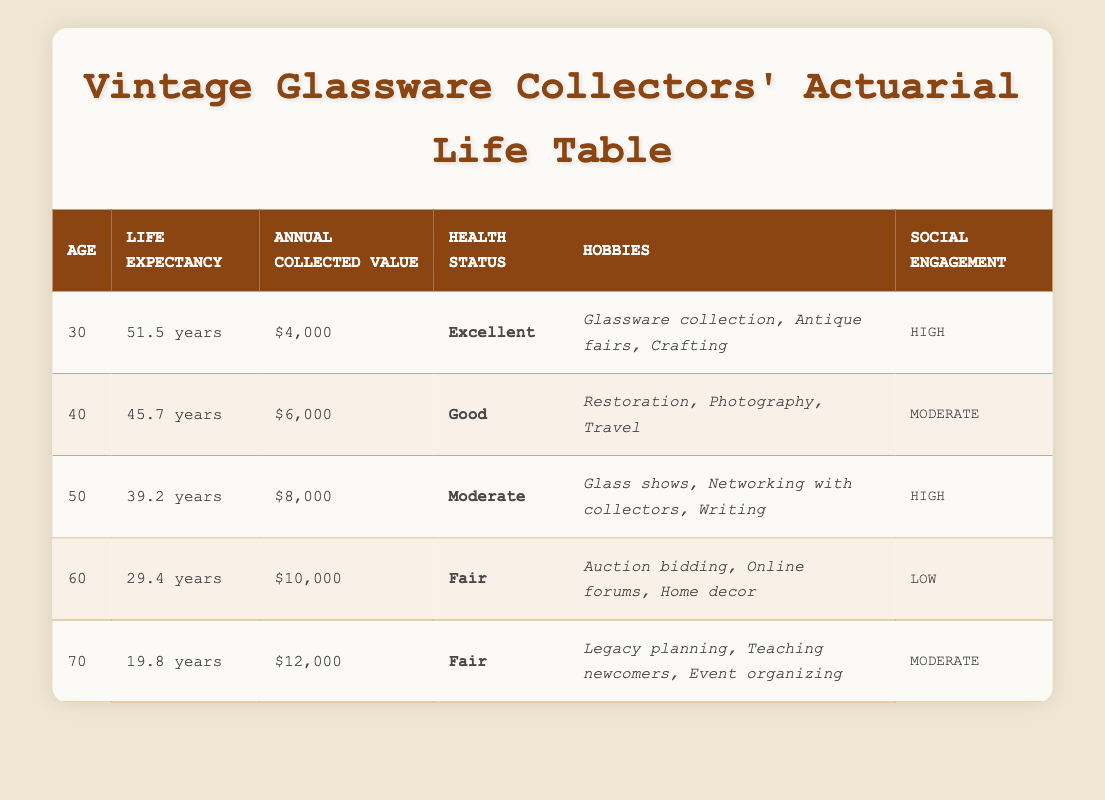What is the life expectancy for a 60-year-old vintage glassware collector? The life expectancy for a 60-year-old collector is directly stated in the table. Checking the row for age 60, it shows a life expectancy of 29.4 years.
Answer: 29.4 years How much is the annual collected value for a 40-year-old collector? By looking at the 40-year age row in the table, the annual collected value listed is $6,000.
Answer: $6,000 What is the age demographic with the highest life expectancy? To find this, we compare all the life expectancy values across the ages listed. The highest life expectancy is 51.5 years for the 30-year-old demographic.
Answer: 30 years Are collectors aged 70 reporting a health status of "Good"? This question requires verification from the health status of the 70-year-old row. The table indicates that the health status for this age is "Fair," not "Good."
Answer: No What is the average annual collected value for collectors aged 50 and 60? To find the average, we first sum the annual collected values for age 50 ($8,000) and age 60 ($10,000). The total is $8,000 + $10,000 = $18,000. Then, we divide by the number of entries (which is 2): $18,000 / 2 = $9,000.
Answer: $9,000 Which age group has the lowest social engagement status? The social engagement statuses are listed in the table. Reviewing them shows that the 60-year age group has a low status, while the other ages are either moderate or high.
Answer: 60 years What is the difference in life expectancy between a 30-year-old collector and a 70-year-old collector? To find the difference, we look at the life expectancies: 30-year-olds have a life expectancy of 51.5 years and 70-year-olds have 19.8 years. The difference is calculated as 51.5 - 19.8 = 31.7 years.
Answer: 31.7 years What hobbies do 50-year-old collectors typically engage in? The table includes a row for age 50, which lists their hobbies. Looking at this row, the hobbies are glass shows, networking with collectors, and writing.
Answer: Glass shows, networking with collectors, writing Is it true that all age groups have a health status of at least "Fair"? By checking each age row in the table, we see that the 30-year and 40-year groups have health statuses of "Excellent" and "Good," respectively, and the 50-year and 60-year groups have "Moderate" and "Fair." Therefore, this statement holds true since 70 also has "Fair."
Answer: Yes 